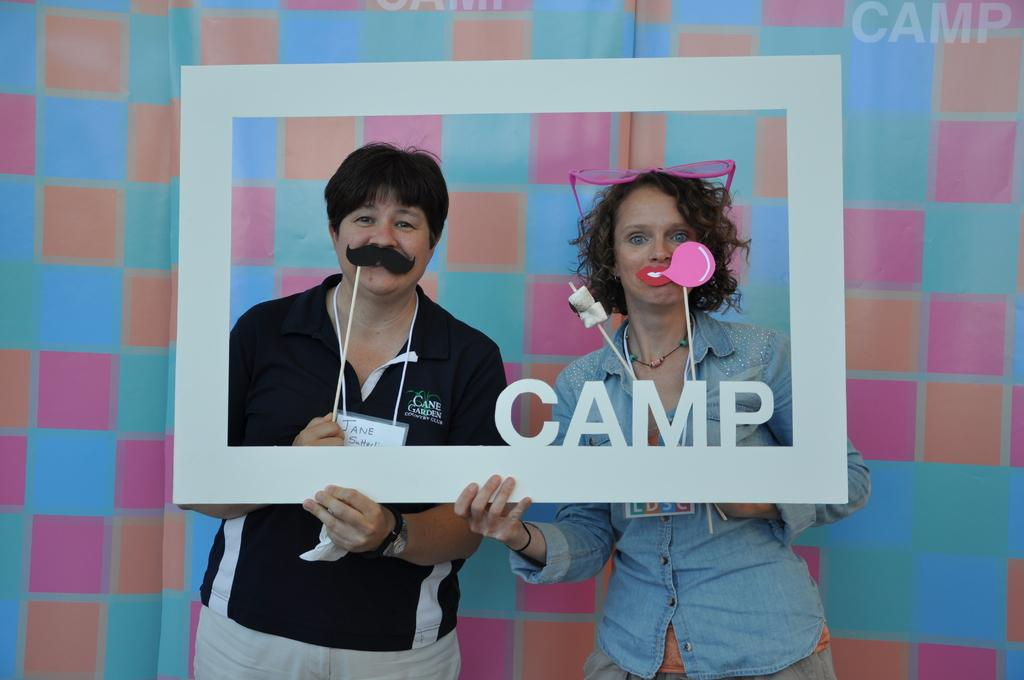What are the two persons in the image doing with the frame? The two persons are holding a frame in the image. What are the two persons watching? The two persons are watching something. What is the person holding in the image? There is a person holding a stick in the image. What can be seen in the background of the image? There is a banner in the background of the image. What is written on the banner? There is text on the banner. What type of disease is being treated by the person holding the stick in the image? There is no indication of a disease or treatment in the image; the person is simply holding a stick. How many bikes are visible in the image? There are no bikes present in the image. 